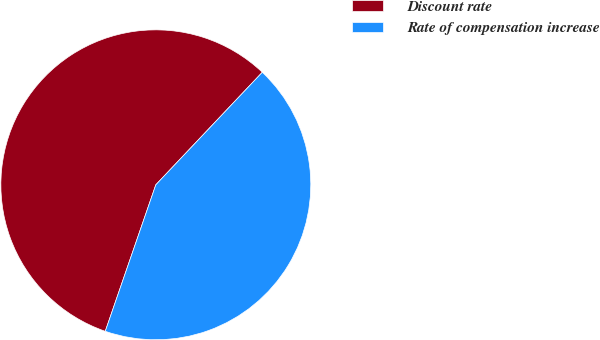Convert chart to OTSL. <chart><loc_0><loc_0><loc_500><loc_500><pie_chart><fcel>Discount rate<fcel>Rate of compensation increase<nl><fcel>56.77%<fcel>43.23%<nl></chart> 